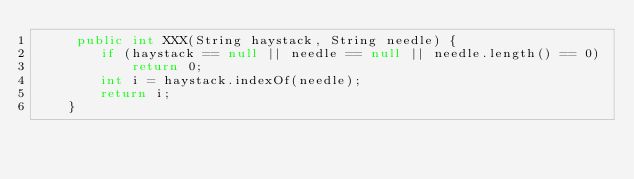<code> <loc_0><loc_0><loc_500><loc_500><_Java_>     public int XXX(String haystack, String needle) {
        if (haystack == null || needle == null || needle.length() == 0)
            return 0;
        int i = haystack.indexOf(needle);
        return i;
    }

</code> 